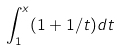<formula> <loc_0><loc_0><loc_500><loc_500>\int _ { 1 } ^ { x } ( 1 + 1 / t ) d t</formula> 